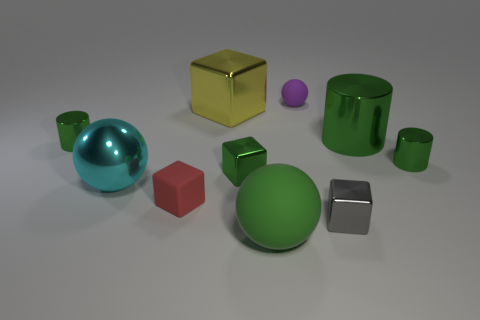What shape is the small object that is right of the purple matte object and in front of the green metallic cube?
Your response must be concise. Cube. What number of other tiny purple things are the same shape as the purple matte thing?
Offer a terse response. 0. What number of big spheres are there?
Keep it short and to the point. 2. What is the size of the ball that is both in front of the yellow metallic block and right of the tiny red thing?
Ensure brevity in your answer.  Large. The gray metal thing that is the same size as the red block is what shape?
Your response must be concise. Cube. Is there a green shiny thing that is behind the small cylinder left of the big metallic sphere?
Your answer should be compact. Yes. There is another matte thing that is the same shape as the big yellow thing; what is its color?
Give a very brief answer. Red. There is a large sphere that is to the left of the yellow block; is it the same color as the big rubber ball?
Ensure brevity in your answer.  No. How many objects are big things that are on the left side of the big green ball or small green metallic blocks?
Ensure brevity in your answer.  3. What is the material of the large green object that is on the left side of the rubber ball behind the matte ball that is in front of the small purple matte sphere?
Provide a succinct answer. Rubber. 